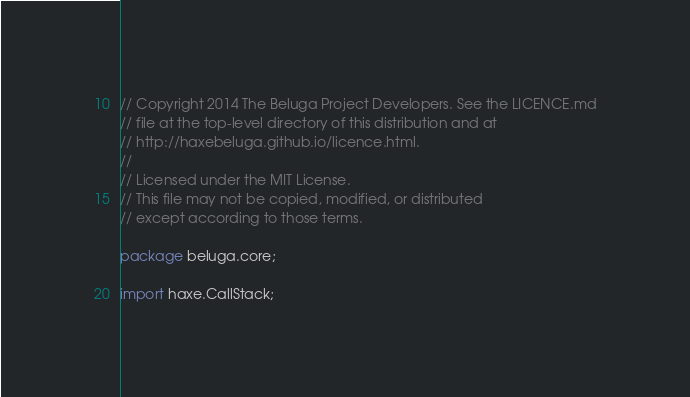<code> <loc_0><loc_0><loc_500><loc_500><_Haxe_>// Copyright 2014 The Beluga Project Developers. See the LICENCE.md
// file at the top-level directory of this distribution and at
// http://haxebeluga.github.io/licence.html.
//
// Licensed under the MIT License.
// This file may not be copied, modified, or distributed
// except according to those terms.

package beluga.core;

import haxe.CallStack;
</code> 